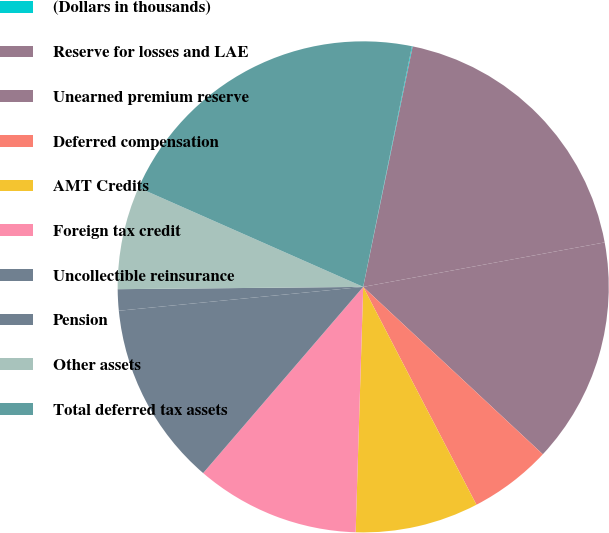Convert chart. <chart><loc_0><loc_0><loc_500><loc_500><pie_chart><fcel>(Dollars in thousands)<fcel>Reserve for losses and LAE<fcel>Unearned premium reserve<fcel>Deferred compensation<fcel>AMT Credits<fcel>Foreign tax credit<fcel>Uncollectible reinsurance<fcel>Pension<fcel>Other assets<fcel>Total deferred tax assets<nl><fcel>0.05%<fcel>18.87%<fcel>14.84%<fcel>5.43%<fcel>8.12%<fcel>10.81%<fcel>12.15%<fcel>1.4%<fcel>6.77%<fcel>21.56%<nl></chart> 